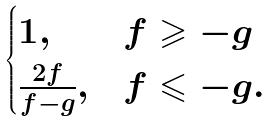<formula> <loc_0><loc_0><loc_500><loc_500>\begin{cases} 1 , & f \geqslant - g \\ \frac { 2 f } { f - g } , & f \leqslant - g . \end{cases}</formula> 